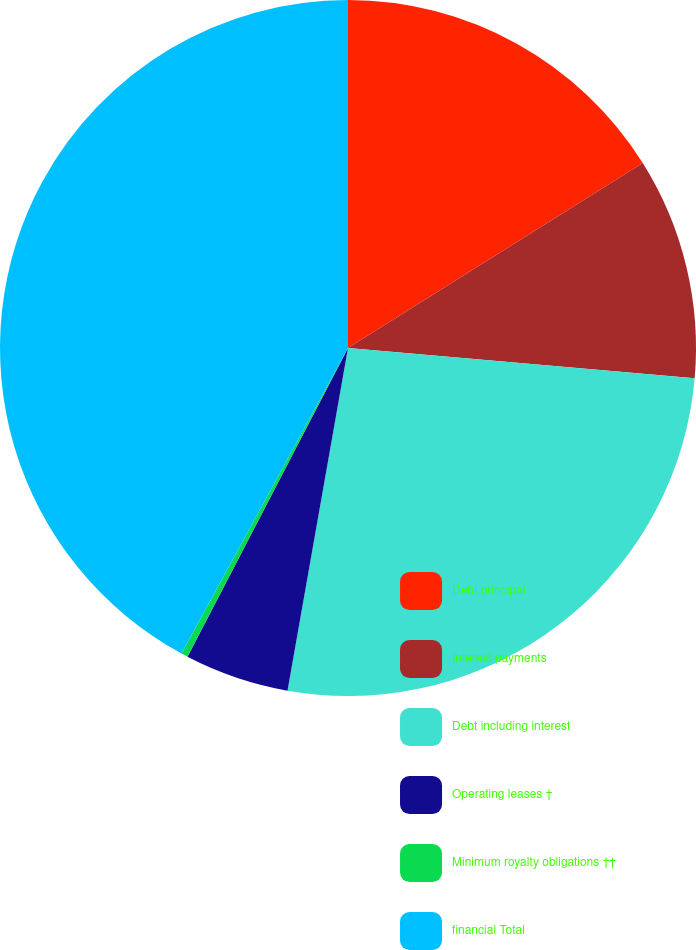Convert chart. <chart><loc_0><loc_0><loc_500><loc_500><pie_chart><fcel>Debt principal<fcel>Interest payments<fcel>Debt including interest<fcel>Operating leases †<fcel>Minimum royalty obligations ††<fcel>financial Total<nl><fcel>16.08%<fcel>10.31%<fcel>26.39%<fcel>4.85%<fcel>0.31%<fcel>42.06%<nl></chart> 